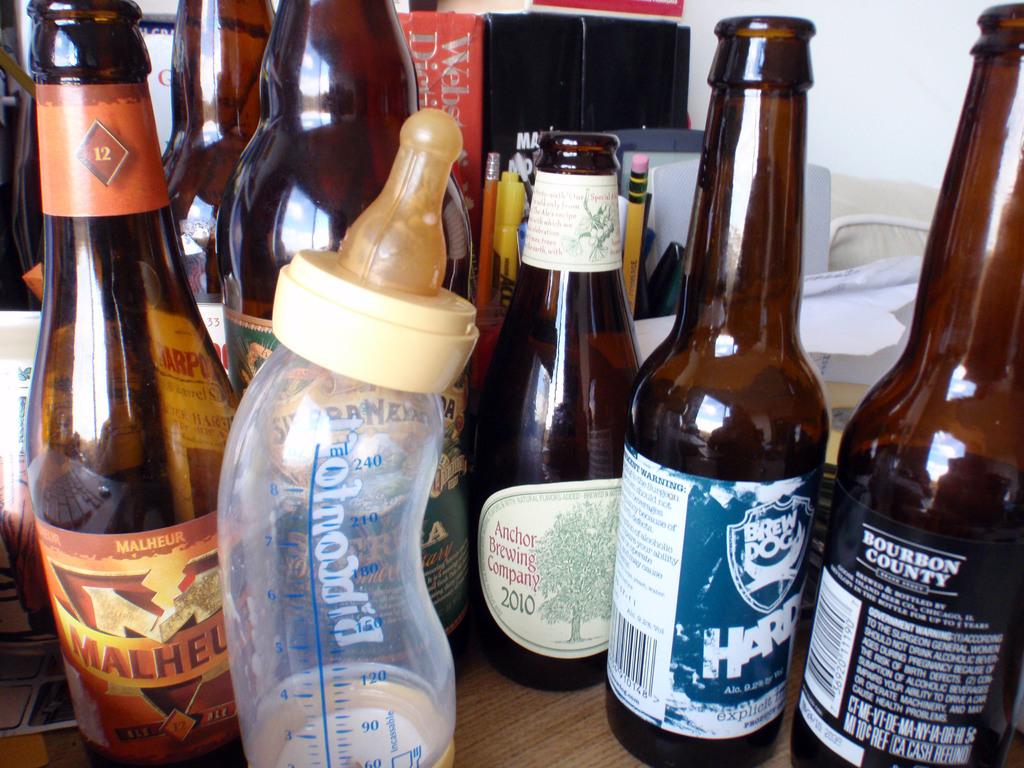Who makes the beer on the right with the blue label?
Provide a short and direct response. Brew dog. What year was the beer made from the anchor brewing company?
Offer a very short reply. 2010. 